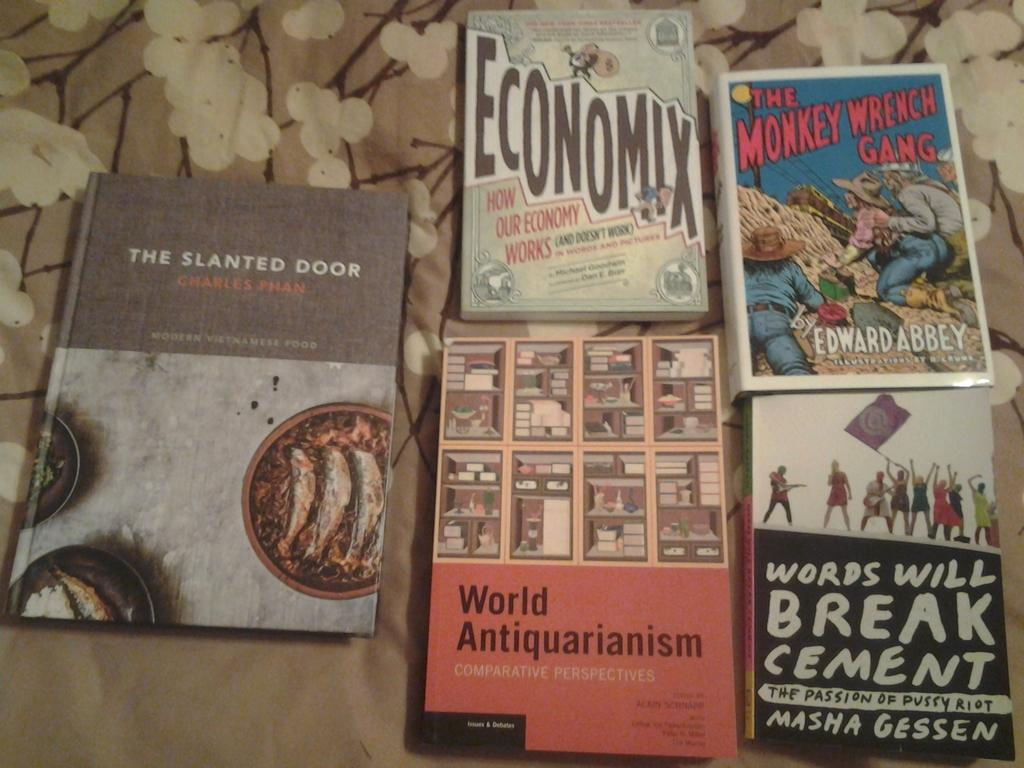<image>
Summarize the visual content of the image. Books placed next to one another with Economix being on top. 